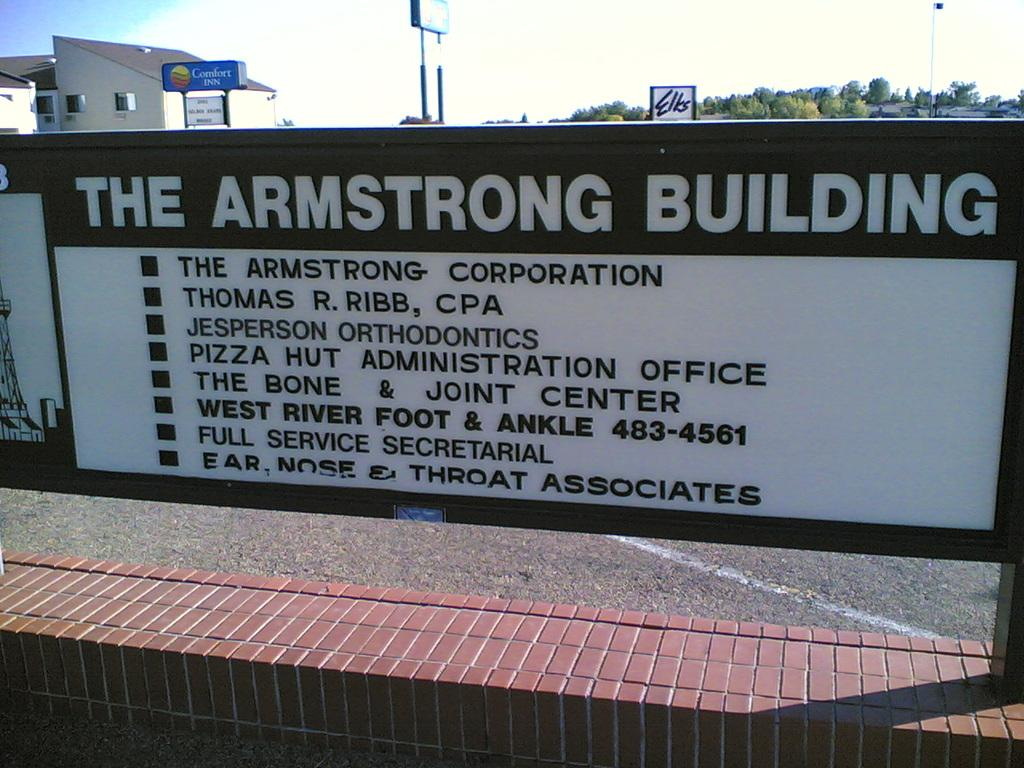<image>
Give a short and clear explanation of the subsequent image. A large sign outside by a brick wall that says The Armstrong Building. 